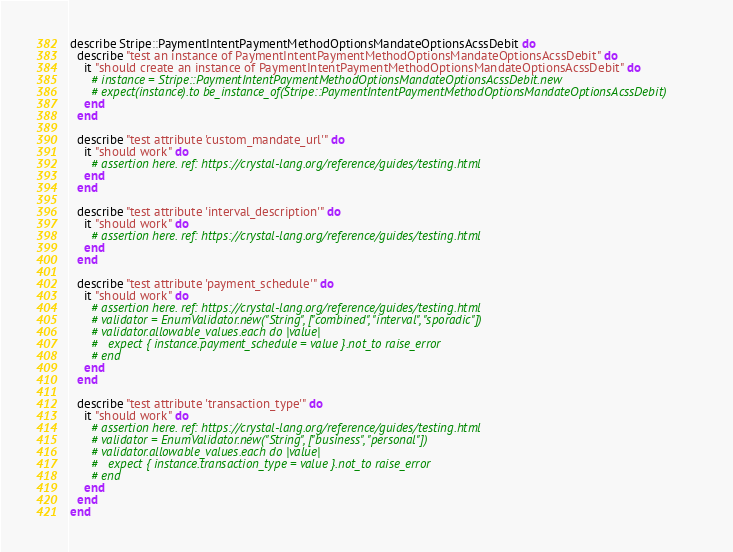<code> <loc_0><loc_0><loc_500><loc_500><_Crystal_>describe Stripe::PaymentIntentPaymentMethodOptionsMandateOptionsAcssDebit do
  describe "test an instance of PaymentIntentPaymentMethodOptionsMandateOptionsAcssDebit" do
    it "should create an instance of PaymentIntentPaymentMethodOptionsMandateOptionsAcssDebit" do
      # instance = Stripe::PaymentIntentPaymentMethodOptionsMandateOptionsAcssDebit.new
      # expect(instance).to be_instance_of(Stripe::PaymentIntentPaymentMethodOptionsMandateOptionsAcssDebit)
    end
  end

  describe "test attribute 'custom_mandate_url'" do
    it "should work" do
      # assertion here. ref: https://crystal-lang.org/reference/guides/testing.html
    end
  end

  describe "test attribute 'interval_description'" do
    it "should work" do
      # assertion here. ref: https://crystal-lang.org/reference/guides/testing.html
    end
  end

  describe "test attribute 'payment_schedule'" do
    it "should work" do
      # assertion here. ref: https://crystal-lang.org/reference/guides/testing.html
      # validator = EnumValidator.new("String", ["combined", "interval", "sporadic"])
      # validator.allowable_values.each do |value|
      #   expect { instance.payment_schedule = value }.not_to raise_error
      # end
    end
  end

  describe "test attribute 'transaction_type'" do
    it "should work" do
      # assertion here. ref: https://crystal-lang.org/reference/guides/testing.html
      # validator = EnumValidator.new("String", ["business", "personal"])
      # validator.allowable_values.each do |value|
      #   expect { instance.transaction_type = value }.not_to raise_error
      # end
    end
  end
end
</code> 